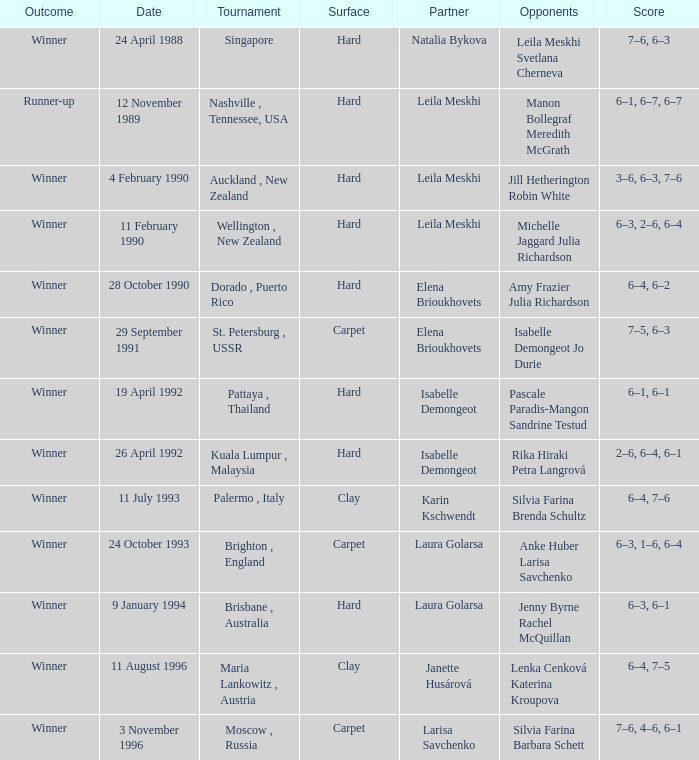Would you mind parsing the complete table? {'header': ['Outcome', 'Date', 'Tournament', 'Surface', 'Partner', 'Opponents', 'Score'], 'rows': [['Winner', '24 April 1988', 'Singapore', 'Hard', 'Natalia Bykova', 'Leila Meskhi Svetlana Cherneva', '7–6, 6–3'], ['Runner-up', '12 November 1989', 'Nashville , Tennessee, USA', 'Hard', 'Leila Meskhi', 'Manon Bollegraf Meredith McGrath', '6–1, 6–7, 6–7'], ['Winner', '4 February 1990', 'Auckland , New Zealand', 'Hard', 'Leila Meskhi', 'Jill Hetherington Robin White', '3–6, 6–3, 7–6'], ['Winner', '11 February 1990', 'Wellington , New Zealand', 'Hard', 'Leila Meskhi', 'Michelle Jaggard Julia Richardson', '6–3, 2–6, 6–4'], ['Winner', '28 October 1990', 'Dorado , Puerto Rico', 'Hard', 'Elena Brioukhovets', 'Amy Frazier Julia Richardson', '6–4, 6–2'], ['Winner', '29 September 1991', 'St. Petersburg , USSR', 'Carpet', 'Elena Brioukhovets', 'Isabelle Demongeot Jo Durie', '7–5, 6–3'], ['Winner', '19 April 1992', 'Pattaya , Thailand', 'Hard', 'Isabelle Demongeot', 'Pascale Paradis-Mangon Sandrine Testud', '6–1, 6–1'], ['Winner', '26 April 1992', 'Kuala Lumpur , Malaysia', 'Hard', 'Isabelle Demongeot', 'Rika Hiraki Petra Langrová', '2–6, 6–4, 6–1'], ['Winner', '11 July 1993', 'Palermo , Italy', 'Clay', 'Karin Kschwendt', 'Silvia Farina Brenda Schultz', '6–4, 7–6'], ['Winner', '24 October 1993', 'Brighton , England', 'Carpet', 'Laura Golarsa', 'Anke Huber Larisa Savchenko', '6–3, 1–6, 6–4'], ['Winner', '9 January 1994', 'Brisbane , Australia', 'Hard', 'Laura Golarsa', 'Jenny Byrne Rachel McQuillan', '6–3, 6–1'], ['Winner', '11 August 1996', 'Maria Lankowitz , Austria', 'Clay', 'Janette Husárová', 'Lenka Cenková Katerina Kroupova', '6–4, 7–5'], ['Winner', '3 November 1996', 'Moscow , Russia', 'Carpet', 'Larisa Savchenko', 'Silvia Farina Barbara Schett', '7–6, 4–6, 6–1']]} In what competition was the outcome of 3-6, 6-3, 7-6 in a match held on a hard ground? Auckland , New Zealand. 